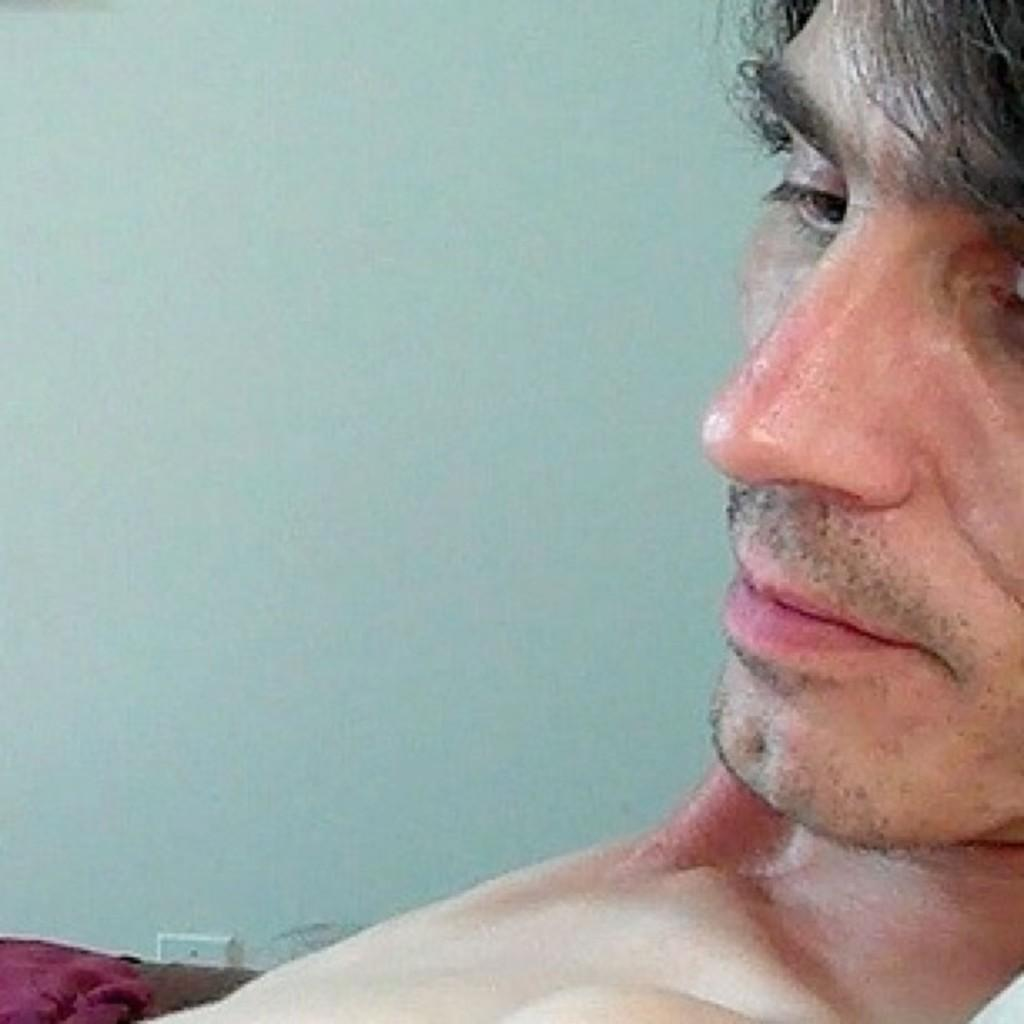Who is the main subject in the front of the image? There is a man in the front of the image. What can be seen on the bottom left side of the image? There is a white color thing and a red color thing on the bottom left side of the image. What is visible in the background of the image? There is a wall visible in the background of the image. What type of operation is being performed by the minister in the image? There is no minister or operation present in the image. What is happening in the back of the image? The provided facts do not mention anything about the back of the image, so we cannot answer this question. 